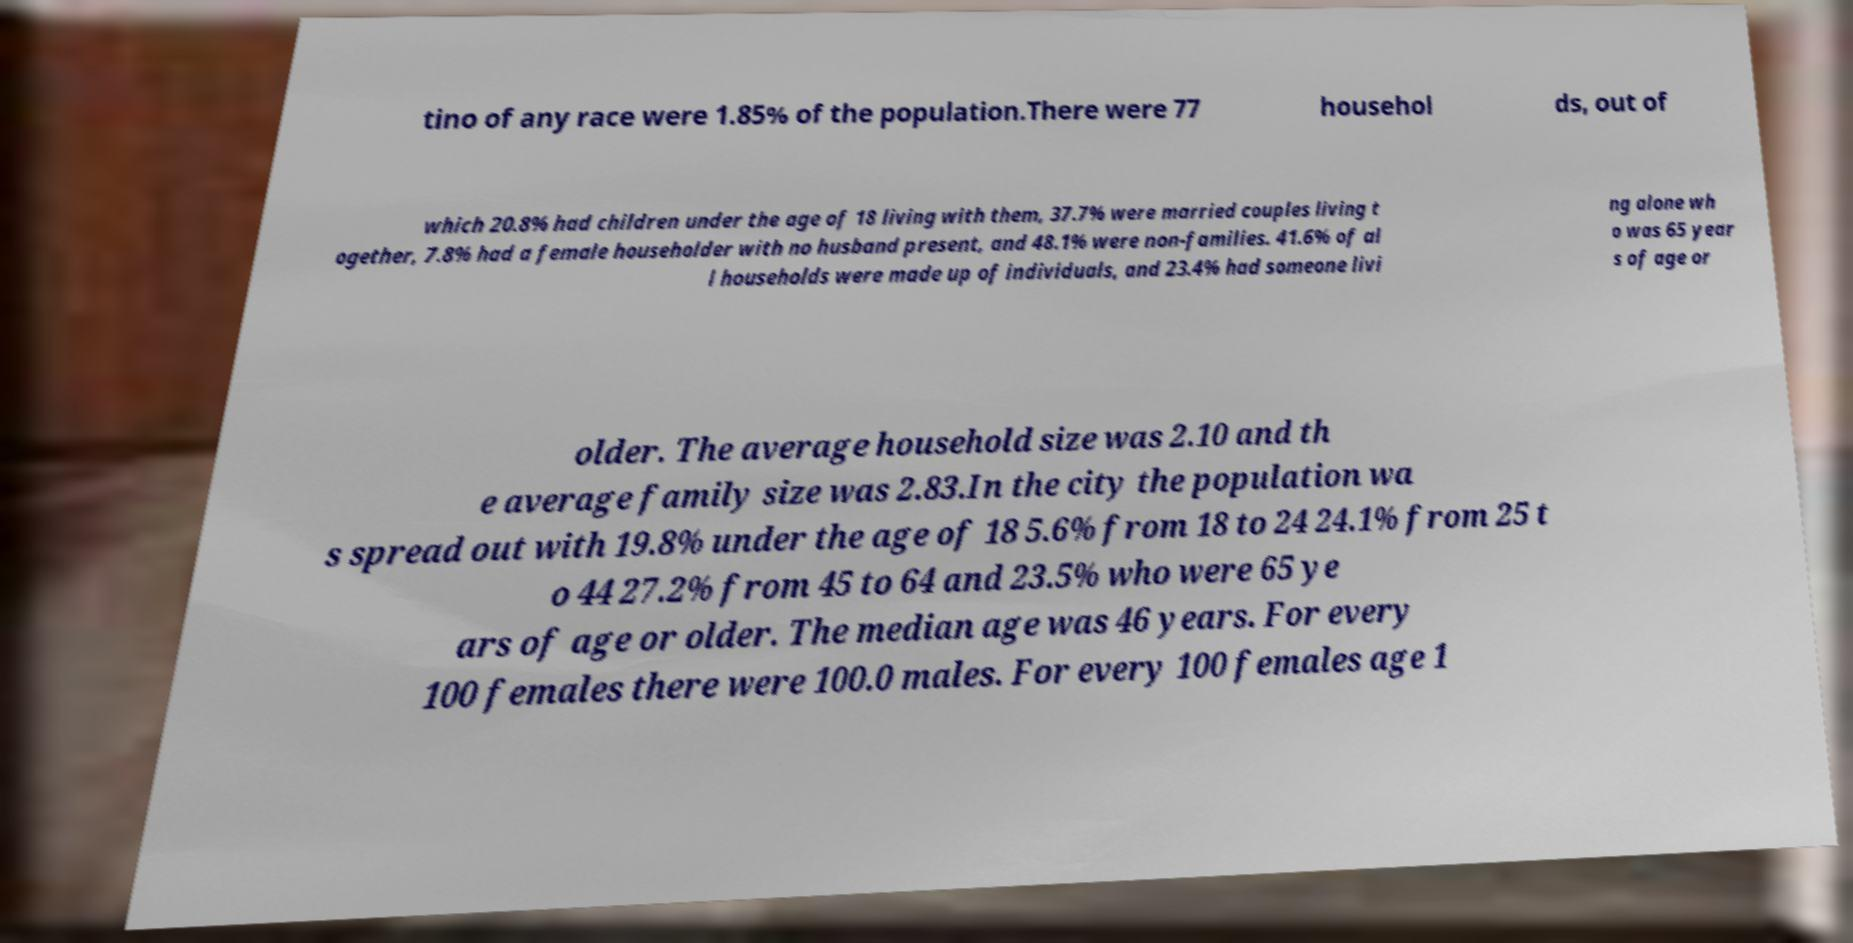Please identify and transcribe the text found in this image. tino of any race were 1.85% of the population.There were 77 househol ds, out of which 20.8% had children under the age of 18 living with them, 37.7% were married couples living t ogether, 7.8% had a female householder with no husband present, and 48.1% were non-families. 41.6% of al l households were made up of individuals, and 23.4% had someone livi ng alone wh o was 65 year s of age or older. The average household size was 2.10 and th e average family size was 2.83.In the city the population wa s spread out with 19.8% under the age of 18 5.6% from 18 to 24 24.1% from 25 t o 44 27.2% from 45 to 64 and 23.5% who were 65 ye ars of age or older. The median age was 46 years. For every 100 females there were 100.0 males. For every 100 females age 1 